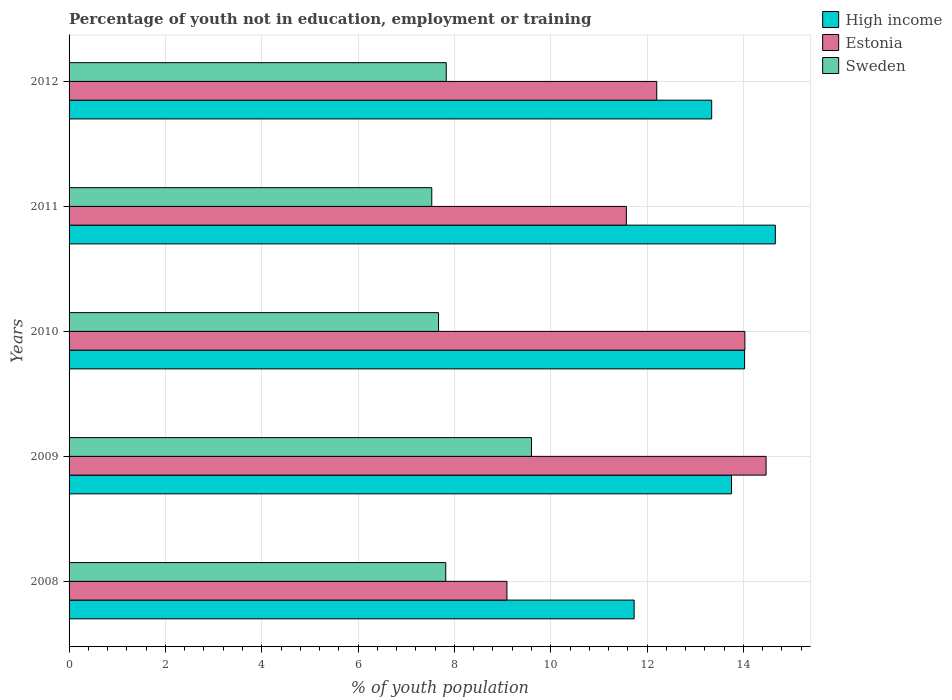How many groups of bars are there?
Make the answer very short. 5. What is the percentage of unemployed youth population in in High income in 2008?
Make the answer very short. 11.73. Across all years, what is the maximum percentage of unemployed youth population in in Sweden?
Keep it short and to the point. 9.6. Across all years, what is the minimum percentage of unemployed youth population in in Sweden?
Offer a very short reply. 7.53. In which year was the percentage of unemployed youth population in in High income maximum?
Provide a short and direct response. 2011. In which year was the percentage of unemployed youth population in in Estonia minimum?
Give a very brief answer. 2008. What is the total percentage of unemployed youth population in in High income in the graph?
Your response must be concise. 67.51. What is the difference between the percentage of unemployed youth population in in Estonia in 2010 and that in 2012?
Provide a short and direct response. 1.83. What is the difference between the percentage of unemployed youth population in in Sweden in 2008 and the percentage of unemployed youth population in in High income in 2012?
Your response must be concise. -5.52. What is the average percentage of unemployed youth population in in High income per year?
Provide a succinct answer. 13.5. In the year 2009, what is the difference between the percentage of unemployed youth population in in Estonia and percentage of unemployed youth population in in High income?
Keep it short and to the point. 0.72. What is the ratio of the percentage of unemployed youth population in in High income in 2008 to that in 2009?
Provide a short and direct response. 0.85. What is the difference between the highest and the second highest percentage of unemployed youth population in in High income?
Ensure brevity in your answer.  0.64. What is the difference between the highest and the lowest percentage of unemployed youth population in in Sweden?
Your answer should be compact. 2.07. In how many years, is the percentage of unemployed youth population in in Sweden greater than the average percentage of unemployed youth population in in Sweden taken over all years?
Offer a very short reply. 1. What does the 1st bar from the top in 2009 represents?
Keep it short and to the point. Sweden. What does the 1st bar from the bottom in 2012 represents?
Your answer should be very brief. High income. How many years are there in the graph?
Provide a short and direct response. 5. What is the difference between two consecutive major ticks on the X-axis?
Offer a terse response. 2. Does the graph contain grids?
Your response must be concise. Yes. Where does the legend appear in the graph?
Offer a terse response. Top right. How many legend labels are there?
Offer a very short reply. 3. How are the legend labels stacked?
Your answer should be compact. Vertical. What is the title of the graph?
Keep it short and to the point. Percentage of youth not in education, employment or training. What is the label or title of the X-axis?
Provide a succinct answer. % of youth population. What is the label or title of the Y-axis?
Provide a short and direct response. Years. What is the % of youth population in High income in 2008?
Your answer should be very brief. 11.73. What is the % of youth population in Estonia in 2008?
Offer a terse response. 9.09. What is the % of youth population in Sweden in 2008?
Give a very brief answer. 7.82. What is the % of youth population of High income in 2009?
Your response must be concise. 13.75. What is the % of youth population in Estonia in 2009?
Your response must be concise. 14.47. What is the % of youth population in Sweden in 2009?
Keep it short and to the point. 9.6. What is the % of youth population of High income in 2010?
Your answer should be compact. 14.02. What is the % of youth population of Estonia in 2010?
Offer a terse response. 14.03. What is the % of youth population of Sweden in 2010?
Give a very brief answer. 7.67. What is the % of youth population in High income in 2011?
Keep it short and to the point. 14.66. What is the % of youth population of Estonia in 2011?
Provide a succinct answer. 11.57. What is the % of youth population in Sweden in 2011?
Provide a short and direct response. 7.53. What is the % of youth population in High income in 2012?
Make the answer very short. 13.34. What is the % of youth population of Estonia in 2012?
Your answer should be very brief. 12.2. What is the % of youth population in Sweden in 2012?
Make the answer very short. 7.83. Across all years, what is the maximum % of youth population of High income?
Provide a succinct answer. 14.66. Across all years, what is the maximum % of youth population in Estonia?
Give a very brief answer. 14.47. Across all years, what is the maximum % of youth population of Sweden?
Your answer should be compact. 9.6. Across all years, what is the minimum % of youth population in High income?
Provide a succinct answer. 11.73. Across all years, what is the minimum % of youth population of Estonia?
Your answer should be compact. 9.09. Across all years, what is the minimum % of youth population in Sweden?
Ensure brevity in your answer.  7.53. What is the total % of youth population of High income in the graph?
Offer a terse response. 67.51. What is the total % of youth population in Estonia in the graph?
Make the answer very short. 61.36. What is the total % of youth population of Sweden in the graph?
Offer a very short reply. 40.45. What is the difference between the % of youth population in High income in 2008 and that in 2009?
Your answer should be very brief. -2.02. What is the difference between the % of youth population in Estonia in 2008 and that in 2009?
Provide a short and direct response. -5.38. What is the difference between the % of youth population of Sweden in 2008 and that in 2009?
Give a very brief answer. -1.78. What is the difference between the % of youth population of High income in 2008 and that in 2010?
Provide a succinct answer. -2.29. What is the difference between the % of youth population of Estonia in 2008 and that in 2010?
Your answer should be compact. -4.94. What is the difference between the % of youth population of Sweden in 2008 and that in 2010?
Your response must be concise. 0.15. What is the difference between the % of youth population in High income in 2008 and that in 2011?
Offer a very short reply. -2.93. What is the difference between the % of youth population in Estonia in 2008 and that in 2011?
Provide a succinct answer. -2.48. What is the difference between the % of youth population of Sweden in 2008 and that in 2011?
Make the answer very short. 0.29. What is the difference between the % of youth population of High income in 2008 and that in 2012?
Provide a succinct answer. -1.61. What is the difference between the % of youth population in Estonia in 2008 and that in 2012?
Offer a terse response. -3.11. What is the difference between the % of youth population of Sweden in 2008 and that in 2012?
Provide a short and direct response. -0.01. What is the difference between the % of youth population of High income in 2009 and that in 2010?
Provide a short and direct response. -0.27. What is the difference between the % of youth population of Estonia in 2009 and that in 2010?
Make the answer very short. 0.44. What is the difference between the % of youth population of Sweden in 2009 and that in 2010?
Your answer should be compact. 1.93. What is the difference between the % of youth population in High income in 2009 and that in 2011?
Offer a very short reply. -0.91. What is the difference between the % of youth population of Sweden in 2009 and that in 2011?
Give a very brief answer. 2.07. What is the difference between the % of youth population of High income in 2009 and that in 2012?
Make the answer very short. 0.41. What is the difference between the % of youth population in Estonia in 2009 and that in 2012?
Make the answer very short. 2.27. What is the difference between the % of youth population in Sweden in 2009 and that in 2012?
Your answer should be compact. 1.77. What is the difference between the % of youth population of High income in 2010 and that in 2011?
Offer a very short reply. -0.64. What is the difference between the % of youth population in Estonia in 2010 and that in 2011?
Offer a terse response. 2.46. What is the difference between the % of youth population in Sweden in 2010 and that in 2011?
Your answer should be very brief. 0.14. What is the difference between the % of youth population in High income in 2010 and that in 2012?
Give a very brief answer. 0.68. What is the difference between the % of youth population of Estonia in 2010 and that in 2012?
Give a very brief answer. 1.83. What is the difference between the % of youth population in Sweden in 2010 and that in 2012?
Provide a succinct answer. -0.16. What is the difference between the % of youth population of High income in 2011 and that in 2012?
Ensure brevity in your answer.  1.32. What is the difference between the % of youth population in Estonia in 2011 and that in 2012?
Offer a very short reply. -0.63. What is the difference between the % of youth population in Sweden in 2011 and that in 2012?
Provide a succinct answer. -0.3. What is the difference between the % of youth population of High income in 2008 and the % of youth population of Estonia in 2009?
Provide a short and direct response. -2.74. What is the difference between the % of youth population of High income in 2008 and the % of youth population of Sweden in 2009?
Your answer should be very brief. 2.13. What is the difference between the % of youth population in Estonia in 2008 and the % of youth population in Sweden in 2009?
Give a very brief answer. -0.51. What is the difference between the % of youth population in High income in 2008 and the % of youth population in Estonia in 2010?
Offer a very short reply. -2.3. What is the difference between the % of youth population of High income in 2008 and the % of youth population of Sweden in 2010?
Provide a short and direct response. 4.06. What is the difference between the % of youth population of Estonia in 2008 and the % of youth population of Sweden in 2010?
Keep it short and to the point. 1.42. What is the difference between the % of youth population in High income in 2008 and the % of youth population in Estonia in 2011?
Give a very brief answer. 0.16. What is the difference between the % of youth population in High income in 2008 and the % of youth population in Sweden in 2011?
Your answer should be compact. 4.2. What is the difference between the % of youth population in Estonia in 2008 and the % of youth population in Sweden in 2011?
Give a very brief answer. 1.56. What is the difference between the % of youth population in High income in 2008 and the % of youth population in Estonia in 2012?
Offer a terse response. -0.47. What is the difference between the % of youth population of High income in 2008 and the % of youth population of Sweden in 2012?
Ensure brevity in your answer.  3.9. What is the difference between the % of youth population of Estonia in 2008 and the % of youth population of Sweden in 2012?
Give a very brief answer. 1.26. What is the difference between the % of youth population of High income in 2009 and the % of youth population of Estonia in 2010?
Offer a very short reply. -0.28. What is the difference between the % of youth population in High income in 2009 and the % of youth population in Sweden in 2010?
Keep it short and to the point. 6.08. What is the difference between the % of youth population in Estonia in 2009 and the % of youth population in Sweden in 2010?
Ensure brevity in your answer.  6.8. What is the difference between the % of youth population in High income in 2009 and the % of youth population in Estonia in 2011?
Your answer should be very brief. 2.18. What is the difference between the % of youth population in High income in 2009 and the % of youth population in Sweden in 2011?
Your answer should be very brief. 6.22. What is the difference between the % of youth population in Estonia in 2009 and the % of youth population in Sweden in 2011?
Keep it short and to the point. 6.94. What is the difference between the % of youth population in High income in 2009 and the % of youth population in Estonia in 2012?
Ensure brevity in your answer.  1.55. What is the difference between the % of youth population in High income in 2009 and the % of youth population in Sweden in 2012?
Offer a very short reply. 5.92. What is the difference between the % of youth population of Estonia in 2009 and the % of youth population of Sweden in 2012?
Provide a succinct answer. 6.64. What is the difference between the % of youth population of High income in 2010 and the % of youth population of Estonia in 2011?
Provide a short and direct response. 2.45. What is the difference between the % of youth population in High income in 2010 and the % of youth population in Sweden in 2011?
Provide a short and direct response. 6.49. What is the difference between the % of youth population of High income in 2010 and the % of youth population of Estonia in 2012?
Make the answer very short. 1.82. What is the difference between the % of youth population of High income in 2010 and the % of youth population of Sweden in 2012?
Make the answer very short. 6.19. What is the difference between the % of youth population in High income in 2011 and the % of youth population in Estonia in 2012?
Provide a succinct answer. 2.46. What is the difference between the % of youth population in High income in 2011 and the % of youth population in Sweden in 2012?
Provide a short and direct response. 6.83. What is the difference between the % of youth population of Estonia in 2011 and the % of youth population of Sweden in 2012?
Give a very brief answer. 3.74. What is the average % of youth population in High income per year?
Your answer should be very brief. 13.5. What is the average % of youth population in Estonia per year?
Offer a very short reply. 12.27. What is the average % of youth population in Sweden per year?
Keep it short and to the point. 8.09. In the year 2008, what is the difference between the % of youth population of High income and % of youth population of Estonia?
Your answer should be compact. 2.64. In the year 2008, what is the difference between the % of youth population of High income and % of youth population of Sweden?
Ensure brevity in your answer.  3.91. In the year 2008, what is the difference between the % of youth population in Estonia and % of youth population in Sweden?
Make the answer very short. 1.27. In the year 2009, what is the difference between the % of youth population in High income and % of youth population in Estonia?
Your answer should be compact. -0.72. In the year 2009, what is the difference between the % of youth population of High income and % of youth population of Sweden?
Provide a succinct answer. 4.15. In the year 2009, what is the difference between the % of youth population in Estonia and % of youth population in Sweden?
Offer a very short reply. 4.87. In the year 2010, what is the difference between the % of youth population in High income and % of youth population in Estonia?
Provide a short and direct response. -0.01. In the year 2010, what is the difference between the % of youth population of High income and % of youth population of Sweden?
Keep it short and to the point. 6.35. In the year 2010, what is the difference between the % of youth population in Estonia and % of youth population in Sweden?
Ensure brevity in your answer.  6.36. In the year 2011, what is the difference between the % of youth population of High income and % of youth population of Estonia?
Keep it short and to the point. 3.09. In the year 2011, what is the difference between the % of youth population in High income and % of youth population in Sweden?
Offer a very short reply. 7.13. In the year 2011, what is the difference between the % of youth population in Estonia and % of youth population in Sweden?
Your answer should be very brief. 4.04. In the year 2012, what is the difference between the % of youth population in High income and % of youth population in Estonia?
Offer a very short reply. 1.14. In the year 2012, what is the difference between the % of youth population of High income and % of youth population of Sweden?
Provide a short and direct response. 5.51. In the year 2012, what is the difference between the % of youth population of Estonia and % of youth population of Sweden?
Provide a short and direct response. 4.37. What is the ratio of the % of youth population of High income in 2008 to that in 2009?
Your answer should be very brief. 0.85. What is the ratio of the % of youth population of Estonia in 2008 to that in 2009?
Provide a short and direct response. 0.63. What is the ratio of the % of youth population in Sweden in 2008 to that in 2009?
Give a very brief answer. 0.81. What is the ratio of the % of youth population of High income in 2008 to that in 2010?
Offer a terse response. 0.84. What is the ratio of the % of youth population in Estonia in 2008 to that in 2010?
Provide a short and direct response. 0.65. What is the ratio of the % of youth population of Sweden in 2008 to that in 2010?
Provide a succinct answer. 1.02. What is the ratio of the % of youth population of High income in 2008 to that in 2011?
Give a very brief answer. 0.8. What is the ratio of the % of youth population of Estonia in 2008 to that in 2011?
Provide a short and direct response. 0.79. What is the ratio of the % of youth population in High income in 2008 to that in 2012?
Ensure brevity in your answer.  0.88. What is the ratio of the % of youth population in Estonia in 2008 to that in 2012?
Offer a terse response. 0.75. What is the ratio of the % of youth population in High income in 2009 to that in 2010?
Keep it short and to the point. 0.98. What is the ratio of the % of youth population of Estonia in 2009 to that in 2010?
Provide a succinct answer. 1.03. What is the ratio of the % of youth population of Sweden in 2009 to that in 2010?
Ensure brevity in your answer.  1.25. What is the ratio of the % of youth population of High income in 2009 to that in 2011?
Your answer should be compact. 0.94. What is the ratio of the % of youth population of Estonia in 2009 to that in 2011?
Your answer should be compact. 1.25. What is the ratio of the % of youth population in Sweden in 2009 to that in 2011?
Your response must be concise. 1.27. What is the ratio of the % of youth population of High income in 2009 to that in 2012?
Your response must be concise. 1.03. What is the ratio of the % of youth population in Estonia in 2009 to that in 2012?
Make the answer very short. 1.19. What is the ratio of the % of youth population of Sweden in 2009 to that in 2012?
Keep it short and to the point. 1.23. What is the ratio of the % of youth population of High income in 2010 to that in 2011?
Provide a succinct answer. 0.96. What is the ratio of the % of youth population of Estonia in 2010 to that in 2011?
Your answer should be very brief. 1.21. What is the ratio of the % of youth population of Sweden in 2010 to that in 2011?
Make the answer very short. 1.02. What is the ratio of the % of youth population of High income in 2010 to that in 2012?
Provide a succinct answer. 1.05. What is the ratio of the % of youth population in Estonia in 2010 to that in 2012?
Offer a terse response. 1.15. What is the ratio of the % of youth population in Sweden in 2010 to that in 2012?
Keep it short and to the point. 0.98. What is the ratio of the % of youth population in High income in 2011 to that in 2012?
Offer a very short reply. 1.1. What is the ratio of the % of youth population of Estonia in 2011 to that in 2012?
Your response must be concise. 0.95. What is the ratio of the % of youth population in Sweden in 2011 to that in 2012?
Offer a very short reply. 0.96. What is the difference between the highest and the second highest % of youth population of High income?
Provide a short and direct response. 0.64. What is the difference between the highest and the second highest % of youth population in Estonia?
Ensure brevity in your answer.  0.44. What is the difference between the highest and the second highest % of youth population in Sweden?
Give a very brief answer. 1.77. What is the difference between the highest and the lowest % of youth population of High income?
Give a very brief answer. 2.93. What is the difference between the highest and the lowest % of youth population of Estonia?
Your answer should be very brief. 5.38. What is the difference between the highest and the lowest % of youth population of Sweden?
Offer a terse response. 2.07. 